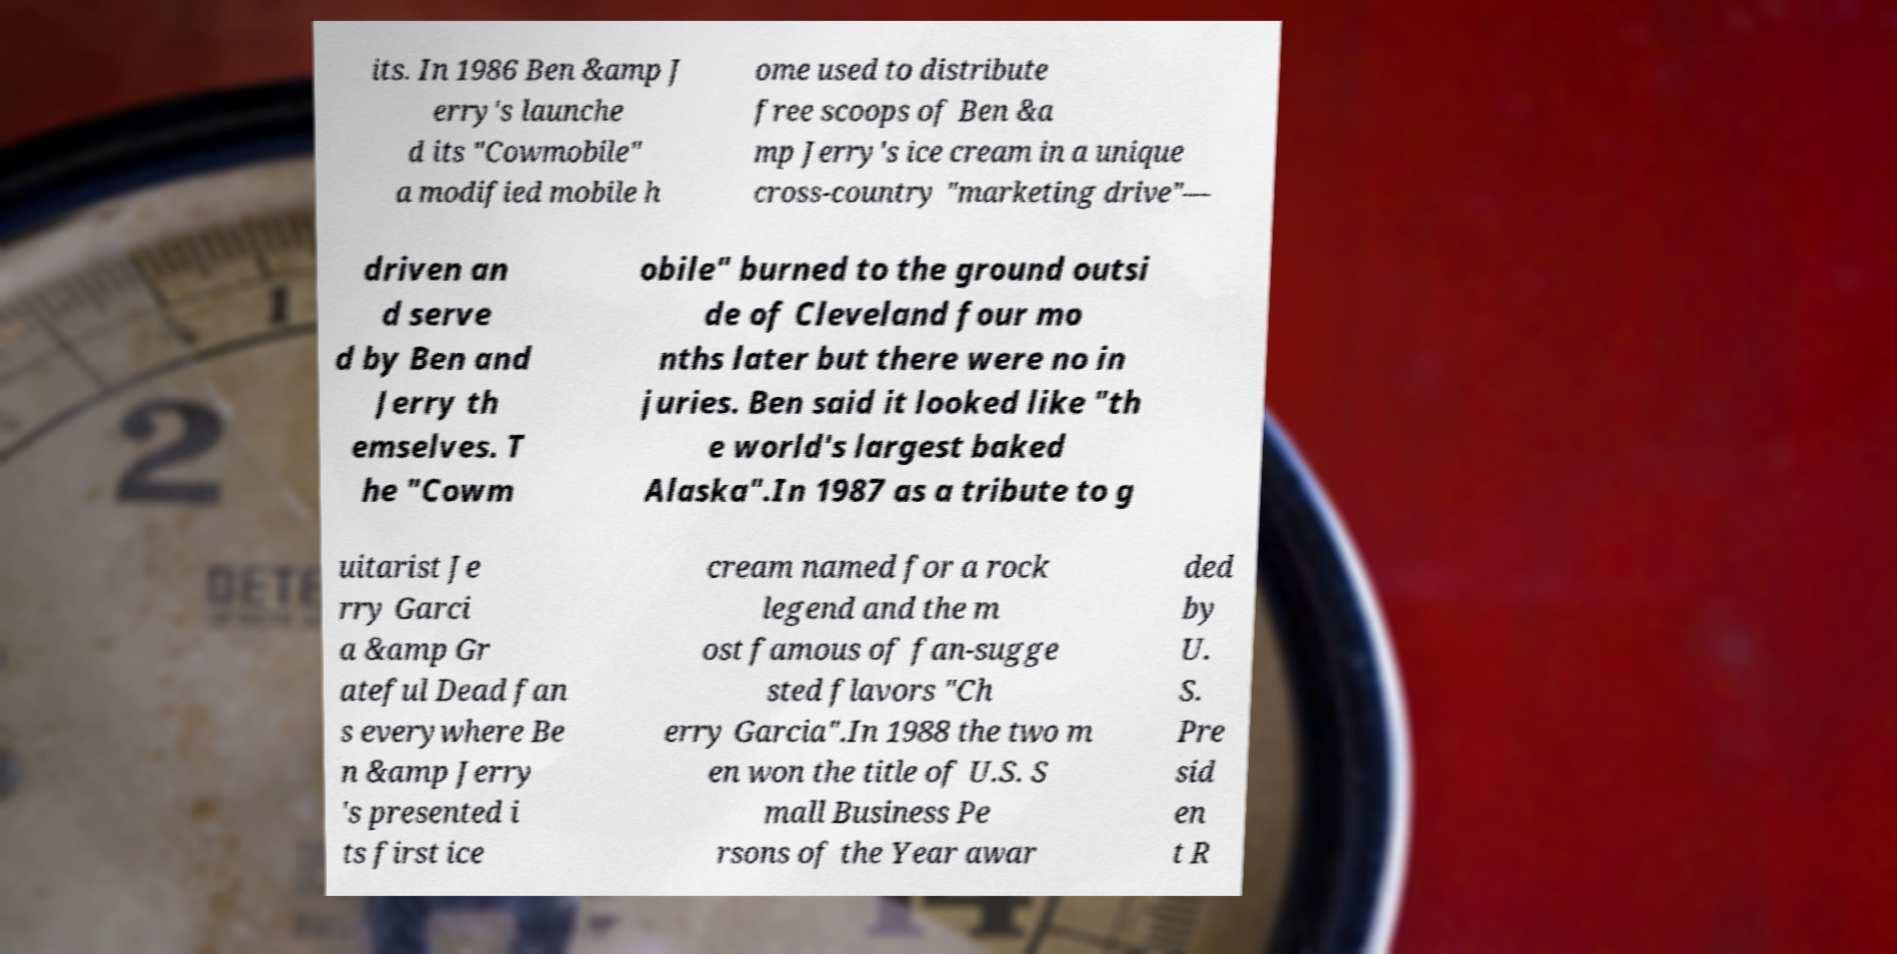Please identify and transcribe the text found in this image. its. In 1986 Ben &amp J erry's launche d its "Cowmobile" a modified mobile h ome used to distribute free scoops of Ben &a mp Jerry's ice cream in a unique cross-country "marketing drive"— driven an d serve d by Ben and Jerry th emselves. T he "Cowm obile" burned to the ground outsi de of Cleveland four mo nths later but there were no in juries. Ben said it looked like "th e world's largest baked Alaska".In 1987 as a tribute to g uitarist Je rry Garci a &amp Gr ateful Dead fan s everywhere Be n &amp Jerry 's presented i ts first ice cream named for a rock legend and the m ost famous of fan-sugge sted flavors "Ch erry Garcia".In 1988 the two m en won the title of U.S. S mall Business Pe rsons of the Year awar ded by U. S. Pre sid en t R 